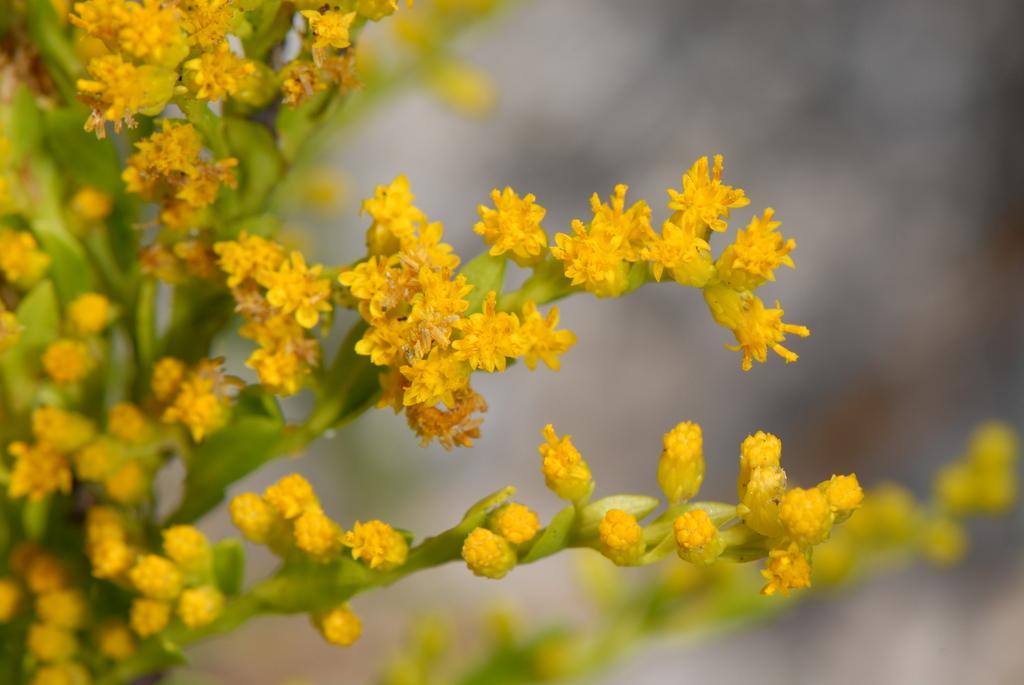Describe this image in one or two sentences. On the left side, there is a plant having yellow color flowers and green color stems. And the background is blurred. 